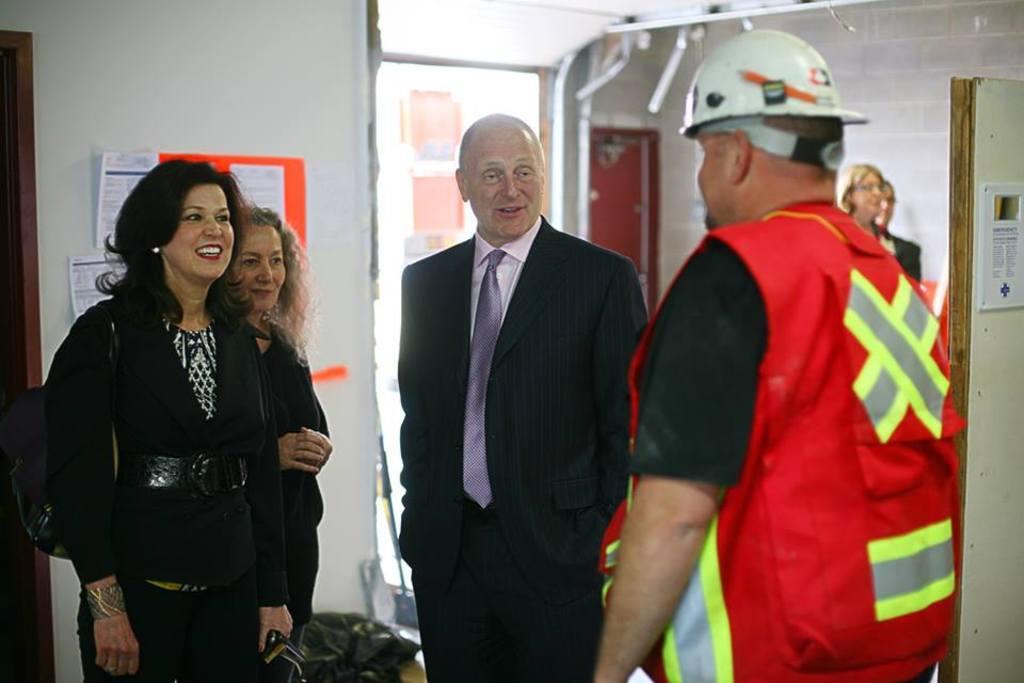Describe this image in one or two sentences. In this image we can see some persons and an object. In the background of the image there is a wall, persons, boards, door and other objects. On the right side of the image there is a door and boards. 